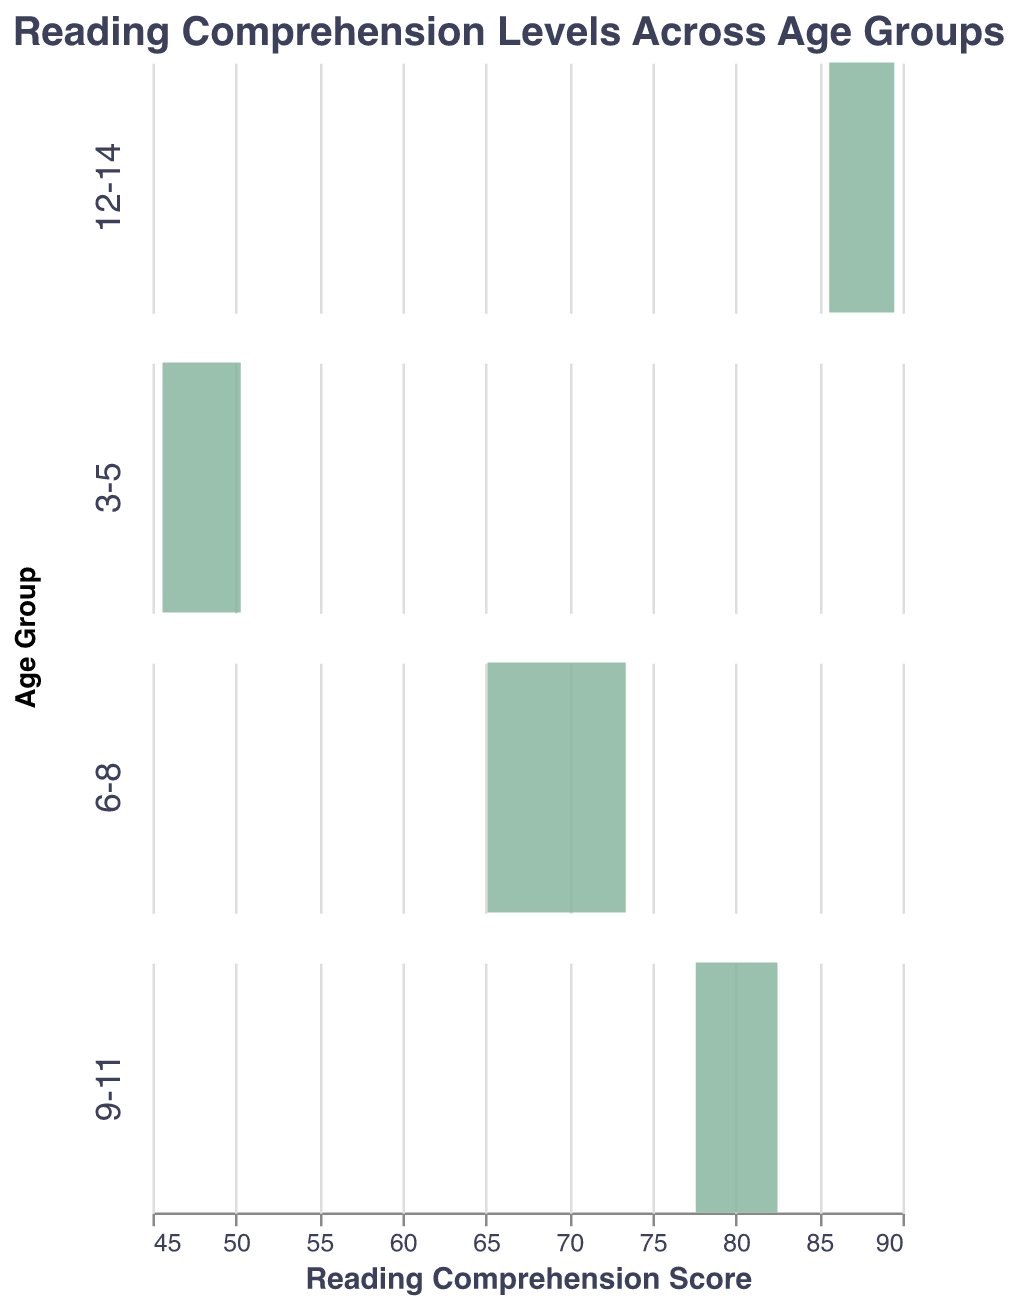What is the title of the figure? The title is usually displayed at the top of the figure and describes the overall theme of the chart. In this case, the title given in the code is "Reading Comprehension Levels Across Age Groups".
Answer: Reading Comprehension Levels Across Age Groups What color are the density plots? The density plots are colored based on the "color" property in the code. Here, the color specified is "#81B29A", which is a shade of green.
Answer: Green How many age groups are represented in the figure? The data is divided into different groups along the row field, which represents age groups. The age groups in the data are "3-5", "6-8", "9-11", and "12-14".
Answer: 4 Which age group has the highest reading comprehension score? By looking at the x-axis of each subplot, we can compare the ranges of reading comprehension scores. The "12-14" age group has scores in the highest range, from 85.6 to 89.5.
Answer: 12-14 What is the general trend of reading comprehension scores across the age groups? To identify the trend, observe the ranges of the scores for each age group: "3-5" (45.6 to 50.3), "6-8" (65.1 to 73.4), "9-11" (77.6 to 82.5), and "12-14" (85.6 to 89.5). The scores increase as the age groups go from younger to older.
Answer: Scores generally increase with age Which age group has the narrowest spread of reading comprehension scores? The spread of scores can be determined by the range of values on the x-axis for each subplot. The narrowest range is for the "9-11" age group, spanning from 77.6 to 82.5.
Answer: 9-11 What is the minimum reading comprehension score for the 6-8 age group? To find the minimum value, look at the leftmost point of the x-axis in the "6-8" subplot. The minimum score is 65.1.
Answer: 65.1 How many data points are there for the "3-5" age group? Count the number of data entries for the "3-5" age group in the provided data. There are 5 entries for this age group.
Answer: 5 Compare the average reading comprehension score between the "6-8" and "9-11" age groups. Calculate the averages for each group. For "6-8" age group: (65.1 + 70.2 + 67.8 + 73.4 + 69.0) / 5 = 69.1. For "9-11" age group: (78.3 + 82.5 + 80.2 + 77.6 + 81.4) / 5 = 80.0. Therefore, the "9-11" age group has a higher average score.
Answer: "9-11" has higher average, 80.0 Which age group shows the greatest variability in reading comprehension scores? Variability can be observed by the range of scores in each age group. The "6-8" age group has the widest range from 65.1 to 73.4, indicating the greatest variability.
Answer: 6-8 